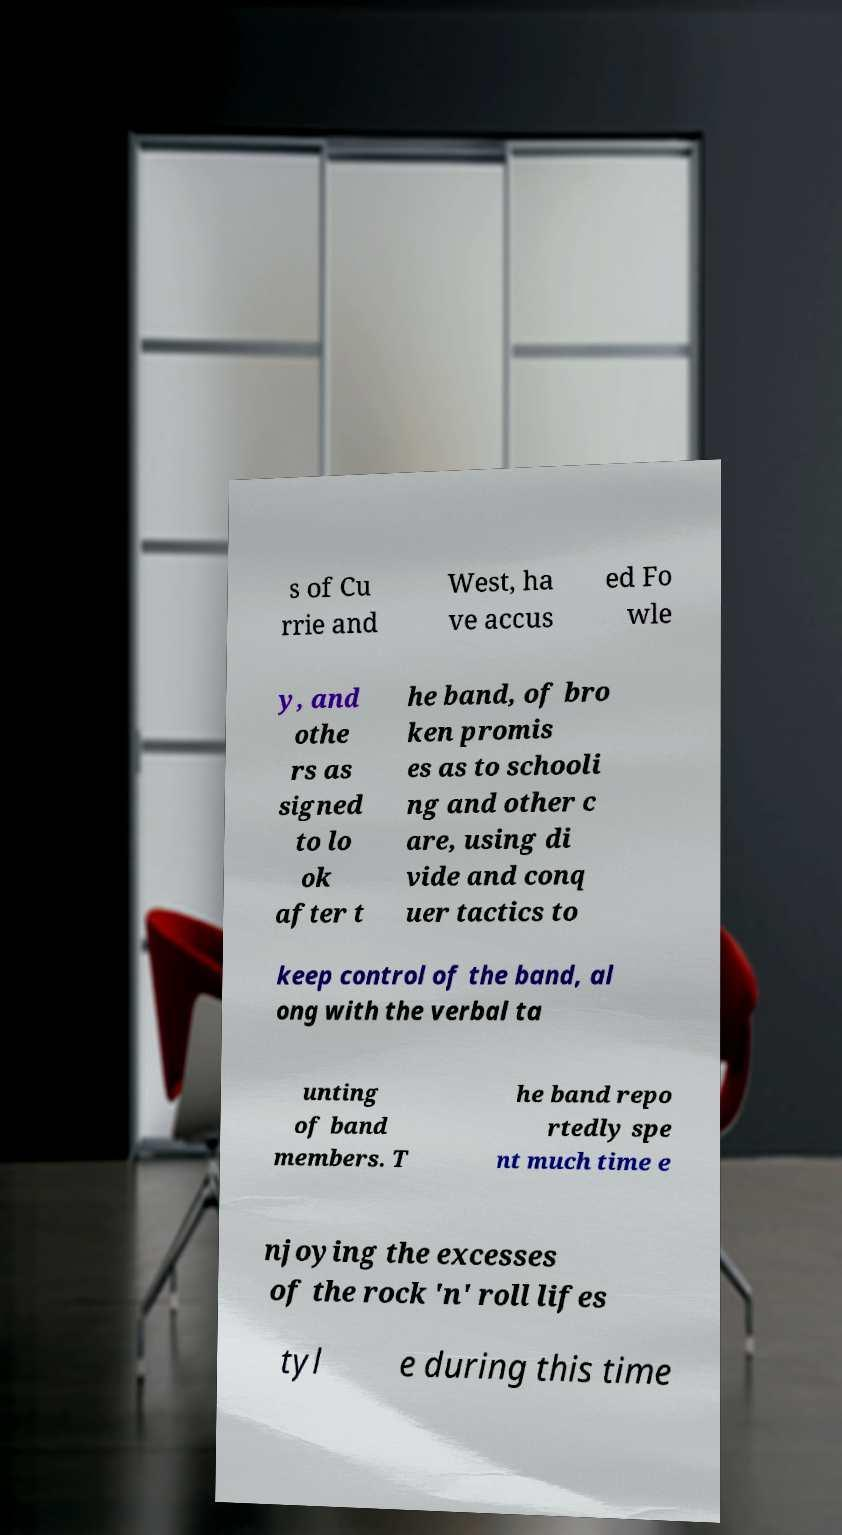Can you read and provide the text displayed in the image?This photo seems to have some interesting text. Can you extract and type it out for me? s of Cu rrie and West, ha ve accus ed Fo wle y, and othe rs as signed to lo ok after t he band, of bro ken promis es as to schooli ng and other c are, using di vide and conq uer tactics to keep control of the band, al ong with the verbal ta unting of band members. T he band repo rtedly spe nt much time e njoying the excesses of the rock 'n' roll lifes tyl e during this time 